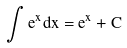Convert formula to latex. <formula><loc_0><loc_0><loc_500><loc_500>\int e ^ { x } d x = e ^ { x } + C</formula> 